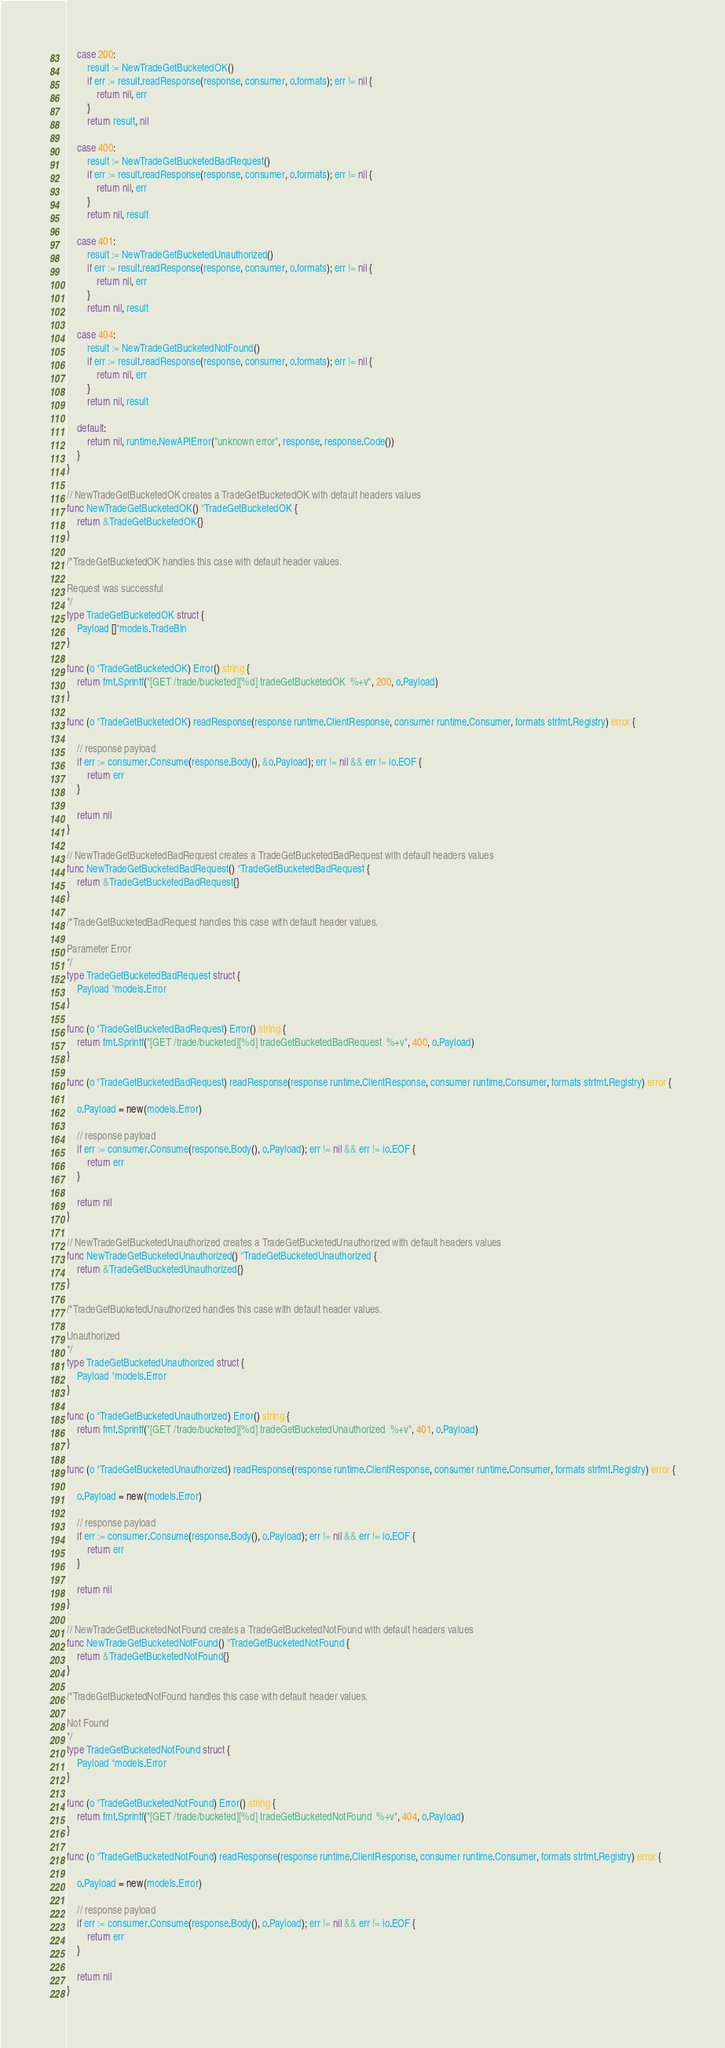Convert code to text. <code><loc_0><loc_0><loc_500><loc_500><_Go_>
	case 200:
		result := NewTradeGetBucketedOK()
		if err := result.readResponse(response, consumer, o.formats); err != nil {
			return nil, err
		}
		return result, nil

	case 400:
		result := NewTradeGetBucketedBadRequest()
		if err := result.readResponse(response, consumer, o.formats); err != nil {
			return nil, err
		}
		return nil, result

	case 401:
		result := NewTradeGetBucketedUnauthorized()
		if err := result.readResponse(response, consumer, o.formats); err != nil {
			return nil, err
		}
		return nil, result

	case 404:
		result := NewTradeGetBucketedNotFound()
		if err := result.readResponse(response, consumer, o.formats); err != nil {
			return nil, err
		}
		return nil, result

	default:
		return nil, runtime.NewAPIError("unknown error", response, response.Code())
	}
}

// NewTradeGetBucketedOK creates a TradeGetBucketedOK with default headers values
func NewTradeGetBucketedOK() *TradeGetBucketedOK {
	return &TradeGetBucketedOK{}
}

/*TradeGetBucketedOK handles this case with default header values.

Request was successful
*/
type TradeGetBucketedOK struct {
	Payload []*models.TradeBin
}

func (o *TradeGetBucketedOK) Error() string {
	return fmt.Sprintf("[GET /trade/bucketed][%d] tradeGetBucketedOK  %+v", 200, o.Payload)
}

func (o *TradeGetBucketedOK) readResponse(response runtime.ClientResponse, consumer runtime.Consumer, formats strfmt.Registry) error {

	// response payload
	if err := consumer.Consume(response.Body(), &o.Payload); err != nil && err != io.EOF {
		return err
	}

	return nil
}

// NewTradeGetBucketedBadRequest creates a TradeGetBucketedBadRequest with default headers values
func NewTradeGetBucketedBadRequest() *TradeGetBucketedBadRequest {
	return &TradeGetBucketedBadRequest{}
}

/*TradeGetBucketedBadRequest handles this case with default header values.

Parameter Error
*/
type TradeGetBucketedBadRequest struct {
	Payload *models.Error
}

func (o *TradeGetBucketedBadRequest) Error() string {
	return fmt.Sprintf("[GET /trade/bucketed][%d] tradeGetBucketedBadRequest  %+v", 400, o.Payload)
}

func (o *TradeGetBucketedBadRequest) readResponse(response runtime.ClientResponse, consumer runtime.Consumer, formats strfmt.Registry) error {

	o.Payload = new(models.Error)

	// response payload
	if err := consumer.Consume(response.Body(), o.Payload); err != nil && err != io.EOF {
		return err
	}

	return nil
}

// NewTradeGetBucketedUnauthorized creates a TradeGetBucketedUnauthorized with default headers values
func NewTradeGetBucketedUnauthorized() *TradeGetBucketedUnauthorized {
	return &TradeGetBucketedUnauthorized{}
}

/*TradeGetBucketedUnauthorized handles this case with default header values.

Unauthorized
*/
type TradeGetBucketedUnauthorized struct {
	Payload *models.Error
}

func (o *TradeGetBucketedUnauthorized) Error() string {
	return fmt.Sprintf("[GET /trade/bucketed][%d] tradeGetBucketedUnauthorized  %+v", 401, o.Payload)
}

func (o *TradeGetBucketedUnauthorized) readResponse(response runtime.ClientResponse, consumer runtime.Consumer, formats strfmt.Registry) error {

	o.Payload = new(models.Error)

	// response payload
	if err := consumer.Consume(response.Body(), o.Payload); err != nil && err != io.EOF {
		return err
	}

	return nil
}

// NewTradeGetBucketedNotFound creates a TradeGetBucketedNotFound with default headers values
func NewTradeGetBucketedNotFound() *TradeGetBucketedNotFound {
	return &TradeGetBucketedNotFound{}
}

/*TradeGetBucketedNotFound handles this case with default header values.

Not Found
*/
type TradeGetBucketedNotFound struct {
	Payload *models.Error
}

func (o *TradeGetBucketedNotFound) Error() string {
	return fmt.Sprintf("[GET /trade/bucketed][%d] tradeGetBucketedNotFound  %+v", 404, o.Payload)
}

func (o *TradeGetBucketedNotFound) readResponse(response runtime.ClientResponse, consumer runtime.Consumer, formats strfmt.Registry) error {

	o.Payload = new(models.Error)

	// response payload
	if err := consumer.Consume(response.Body(), o.Payload); err != nil && err != io.EOF {
		return err
	}

	return nil
}
</code> 